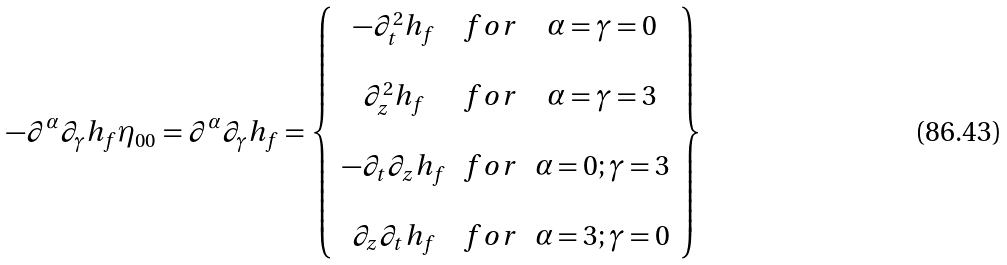Convert formula to latex. <formula><loc_0><loc_0><loc_500><loc_500>- \partial ^ { \alpha } \partial _ { \gamma } h _ { f } \eta _ { 0 0 } = \partial ^ { \alpha } \partial _ { \gamma } h _ { f } = \left \{ \begin{array} { c c c } - \partial _ { t } ^ { 2 } h _ { f } & f o r & \alpha = \gamma = 0 \\ \\ \partial _ { z } ^ { 2 } h _ { f } & f o r & \alpha = \gamma = 3 \\ \\ - \partial _ { t } \partial _ { z } h _ { f } & f o r & \alpha = 0 ; \gamma = 3 \\ \\ \partial _ { z } \partial _ { t } h _ { f } & f o r & \alpha = 3 ; \gamma = 0 \end{array} \right \}</formula> 